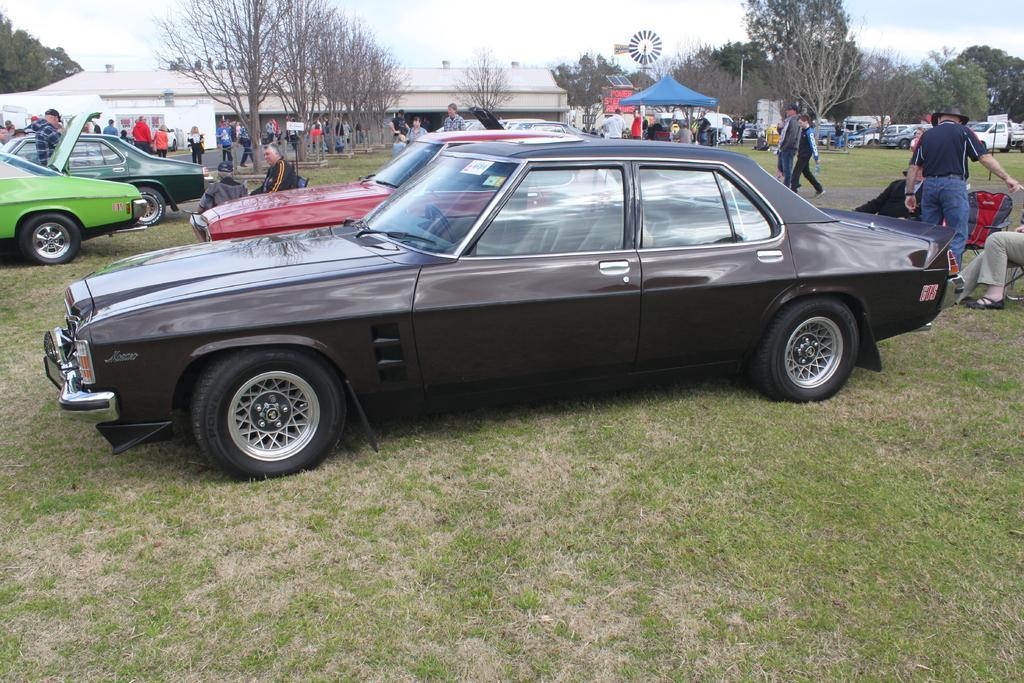Can you describe this image briefly? In this picture I can see few cars and few people walking and few are standing and few are seated on the chairs and I can see a tent and few people seated under it and I can see trees, building and a cloudy sky and I can see grass on the ground and looks like a windmill the back. 